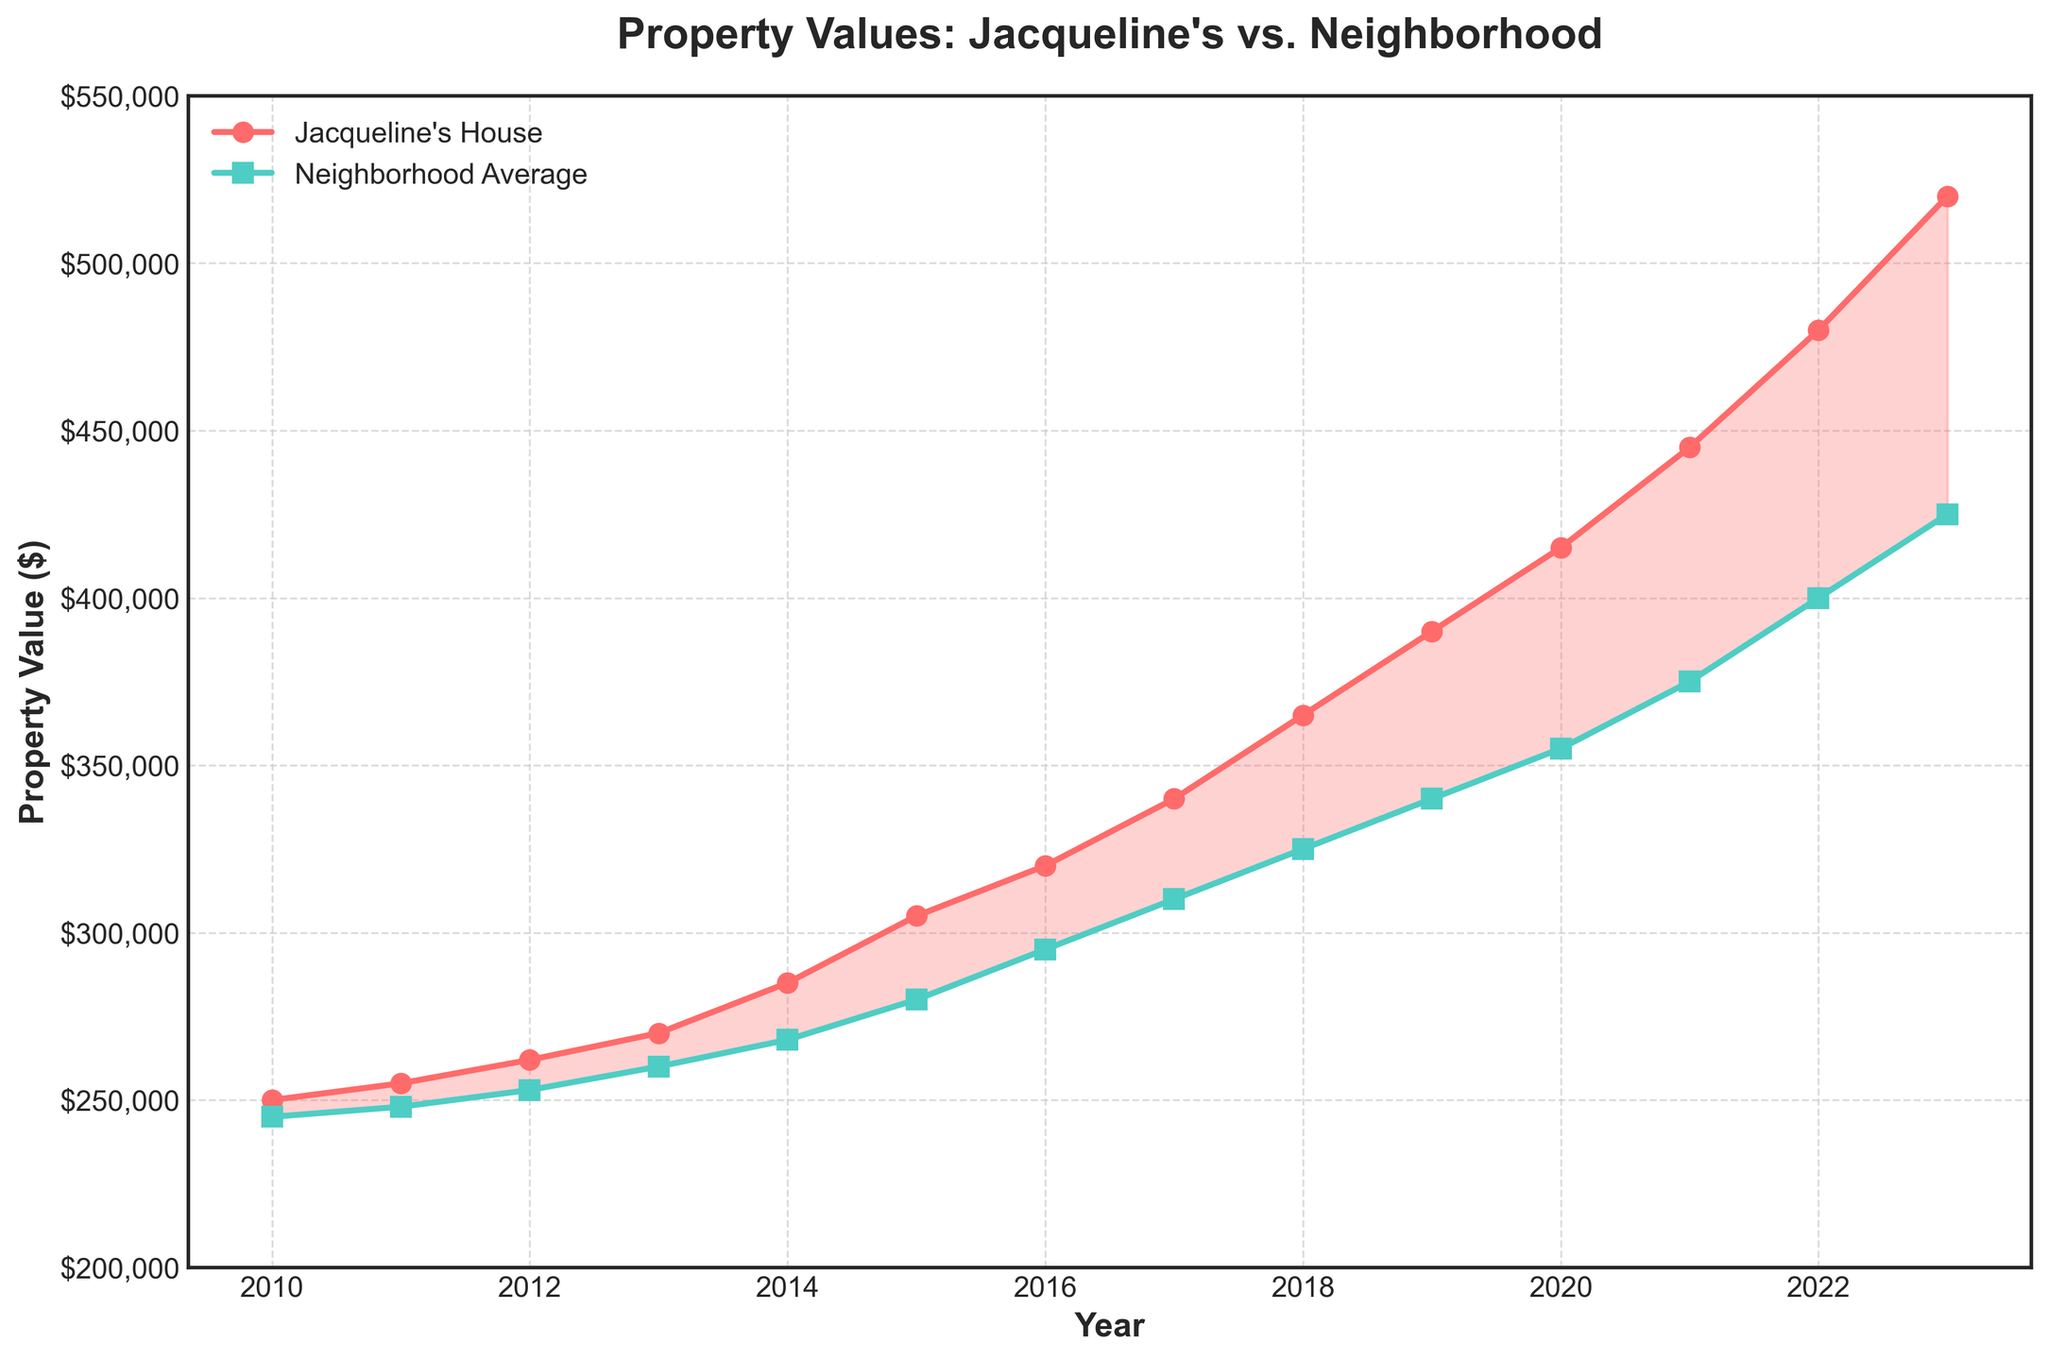What is the value of Jacqueline's house in 2015? Look at the data point corresponding to the year 2015 for Jacqueline's house. The value is marked clearly.
Answer: $305,000 How does the property value of Jacqueline's house in 2020 compare to the neighborhood average in the same year? Compare the data points for 2020. Jacqueline's house has a value of $415,000 and the neighborhood average is $355,000. Jacqueline's house value is higher.
Answer: Jacqueline's house value is higher What is the difference in property value between Jacqueline's house and the neighborhood average in 2023? Find the values for 2023. Jacqueline's house is $520,000 and the neighborhood average is $425,000. Subtract the neighborhood average from Jacqueline's house value, $520,000 - $425,000.
Answer: $95,000 How much did the value of Jacqueline's house increase from 2010 to 2023? Find the values for 2010 and 2023. Jacqueline's house was $250,000 in 2010 and $520,000 in 2023. The increase is $520,000 - $250,000.
Answer: $270,000 Between which two consecutive years did the property value of Jacqueline's house see the largest increase? Check the year-to-year increments. The increases are as follows: (2011-2010) $5,000, (2012-2011) $7,000, (2013-2012) $8,000, (2014-2013) $15,000, (2015-2014) $20,000, (2016-2015) $15,000, (2017-2016) $20,000, (2018-2017) $25,000, (2019-2018) $25,000, (2020-2019) $25,000, (2021-2020) $30,000, (2022-2021) $35,000, (2023-2022) $40,000. The largest increase is between 2022 and 2023.
Answer: 2022 and 2023 What trend is shown by the gap between Jacqueline's house value and the neighborhood average over the years? Look at the variation of the gap between the two lines over the years. The gap generally widens, showing Jacqueline's house increasing in value more rapidly than the neighborhood average.
Answer: The gap widens over the years During which years was the property value of Jacqueline's house below the neighborhood average? Look at the filled areas between the two lines. Jacqueline's house value is always above the neighborhood average from 2010 to 2023.
Answer: None What was the average annual growth in property value for Jacqueline's house from 2010 to 2023? Calculate the total increase from 2010 ($250,000) to 2023 ($520,000), which is $270,000. There are 13 years between 2010 and 2023. The average annual growth is $270,000 / 13.
Answer: $20,769.23 Which year had the highest average property value in the neighborhood? Look for the highest data point in the green line representing the neighborhood average. The highest value is in 2023 at $425,000.
Answer: 2023 